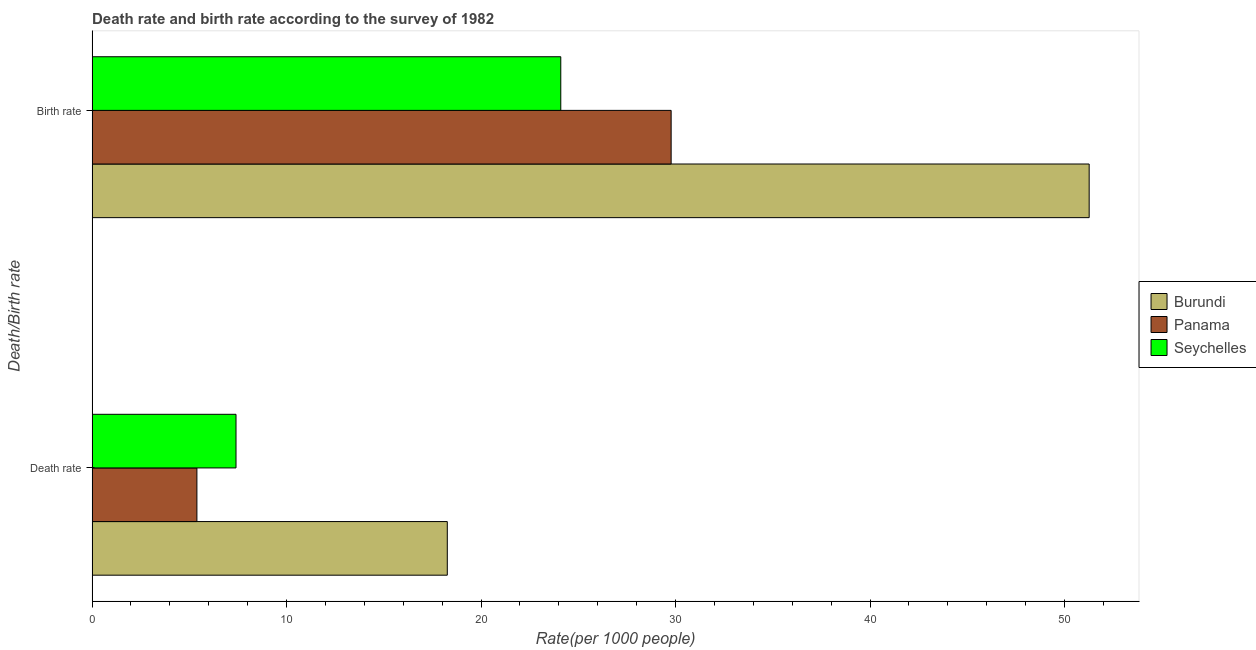How many different coloured bars are there?
Keep it short and to the point. 3. How many groups of bars are there?
Give a very brief answer. 2. Are the number of bars per tick equal to the number of legend labels?
Offer a very short reply. Yes. What is the label of the 2nd group of bars from the top?
Provide a succinct answer. Death rate. What is the death rate in Burundi?
Offer a very short reply. 18.26. Across all countries, what is the maximum birth rate?
Offer a very short reply. 51.27. Across all countries, what is the minimum birth rate?
Offer a terse response. 24.1. In which country was the death rate maximum?
Your answer should be very brief. Burundi. In which country was the birth rate minimum?
Your response must be concise. Seychelles. What is the total death rate in the graph?
Offer a terse response. 31.05. What is the difference between the death rate in Burundi and that in Panama?
Your answer should be compact. 12.88. What is the difference between the death rate in Burundi and the birth rate in Panama?
Your answer should be compact. -11.51. What is the average death rate per country?
Provide a succinct answer. 10.35. What is the difference between the birth rate and death rate in Seychelles?
Make the answer very short. 16.7. What is the ratio of the birth rate in Seychelles to that in Panama?
Give a very brief answer. 0.81. What does the 1st bar from the top in Death rate represents?
Keep it short and to the point. Seychelles. What does the 3rd bar from the bottom in Birth rate represents?
Your response must be concise. Seychelles. How many bars are there?
Ensure brevity in your answer.  6. What is the difference between two consecutive major ticks on the X-axis?
Ensure brevity in your answer.  10. Are the values on the major ticks of X-axis written in scientific E-notation?
Offer a terse response. No. What is the title of the graph?
Make the answer very short. Death rate and birth rate according to the survey of 1982. Does "Hong Kong" appear as one of the legend labels in the graph?
Offer a terse response. No. What is the label or title of the X-axis?
Your response must be concise. Rate(per 1000 people). What is the label or title of the Y-axis?
Make the answer very short. Death/Birth rate. What is the Rate(per 1000 people) in Burundi in Death rate?
Keep it short and to the point. 18.26. What is the Rate(per 1000 people) in Panama in Death rate?
Keep it short and to the point. 5.39. What is the Rate(per 1000 people) in Burundi in Birth rate?
Offer a very short reply. 51.27. What is the Rate(per 1000 people) of Panama in Birth rate?
Make the answer very short. 29.77. What is the Rate(per 1000 people) of Seychelles in Birth rate?
Your response must be concise. 24.1. Across all Death/Birth rate, what is the maximum Rate(per 1000 people) of Burundi?
Your answer should be very brief. 51.27. Across all Death/Birth rate, what is the maximum Rate(per 1000 people) of Panama?
Keep it short and to the point. 29.77. Across all Death/Birth rate, what is the maximum Rate(per 1000 people) in Seychelles?
Offer a terse response. 24.1. Across all Death/Birth rate, what is the minimum Rate(per 1000 people) in Burundi?
Provide a succinct answer. 18.26. Across all Death/Birth rate, what is the minimum Rate(per 1000 people) in Panama?
Offer a very short reply. 5.39. Across all Death/Birth rate, what is the minimum Rate(per 1000 people) in Seychelles?
Your answer should be compact. 7.4. What is the total Rate(per 1000 people) of Burundi in the graph?
Provide a short and direct response. 69.53. What is the total Rate(per 1000 people) in Panama in the graph?
Provide a short and direct response. 35.16. What is the total Rate(per 1000 people) of Seychelles in the graph?
Make the answer very short. 31.5. What is the difference between the Rate(per 1000 people) in Burundi in Death rate and that in Birth rate?
Provide a succinct answer. -33.01. What is the difference between the Rate(per 1000 people) of Panama in Death rate and that in Birth rate?
Your answer should be very brief. -24.39. What is the difference between the Rate(per 1000 people) in Seychelles in Death rate and that in Birth rate?
Your response must be concise. -16.7. What is the difference between the Rate(per 1000 people) of Burundi in Death rate and the Rate(per 1000 people) of Panama in Birth rate?
Offer a very short reply. -11.51. What is the difference between the Rate(per 1000 people) in Burundi in Death rate and the Rate(per 1000 people) in Seychelles in Birth rate?
Your answer should be very brief. -5.84. What is the difference between the Rate(per 1000 people) in Panama in Death rate and the Rate(per 1000 people) in Seychelles in Birth rate?
Keep it short and to the point. -18.71. What is the average Rate(per 1000 people) in Burundi per Death/Birth rate?
Give a very brief answer. 34.77. What is the average Rate(per 1000 people) in Panama per Death/Birth rate?
Offer a very short reply. 17.58. What is the average Rate(per 1000 people) of Seychelles per Death/Birth rate?
Your answer should be compact. 15.75. What is the difference between the Rate(per 1000 people) in Burundi and Rate(per 1000 people) in Panama in Death rate?
Give a very brief answer. 12.88. What is the difference between the Rate(per 1000 people) in Burundi and Rate(per 1000 people) in Seychelles in Death rate?
Ensure brevity in your answer.  10.86. What is the difference between the Rate(per 1000 people) of Panama and Rate(per 1000 people) of Seychelles in Death rate?
Offer a very short reply. -2.01. What is the difference between the Rate(per 1000 people) in Burundi and Rate(per 1000 people) in Panama in Birth rate?
Your answer should be compact. 21.5. What is the difference between the Rate(per 1000 people) of Burundi and Rate(per 1000 people) of Seychelles in Birth rate?
Your response must be concise. 27.17. What is the difference between the Rate(per 1000 people) in Panama and Rate(per 1000 people) in Seychelles in Birth rate?
Offer a very short reply. 5.67. What is the ratio of the Rate(per 1000 people) of Burundi in Death rate to that in Birth rate?
Provide a short and direct response. 0.36. What is the ratio of the Rate(per 1000 people) of Panama in Death rate to that in Birth rate?
Your response must be concise. 0.18. What is the ratio of the Rate(per 1000 people) of Seychelles in Death rate to that in Birth rate?
Offer a very short reply. 0.31. What is the difference between the highest and the second highest Rate(per 1000 people) of Burundi?
Your answer should be compact. 33.01. What is the difference between the highest and the second highest Rate(per 1000 people) in Panama?
Ensure brevity in your answer.  24.39. What is the difference between the highest and the lowest Rate(per 1000 people) of Burundi?
Give a very brief answer. 33.01. What is the difference between the highest and the lowest Rate(per 1000 people) in Panama?
Offer a very short reply. 24.39. 